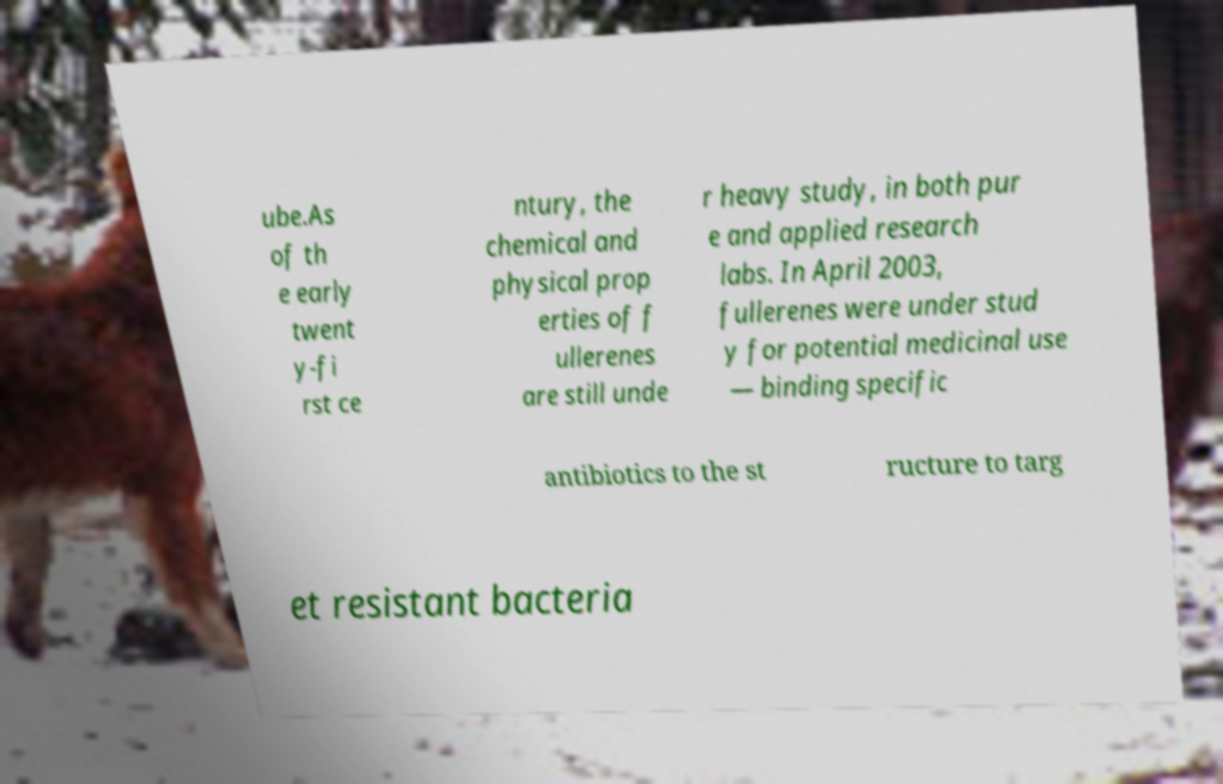Could you assist in decoding the text presented in this image and type it out clearly? ube.As of th e early twent y-fi rst ce ntury, the chemical and physical prop erties of f ullerenes are still unde r heavy study, in both pur e and applied research labs. In April 2003, fullerenes were under stud y for potential medicinal use — binding specific antibiotics to the st ructure to targ et resistant bacteria 